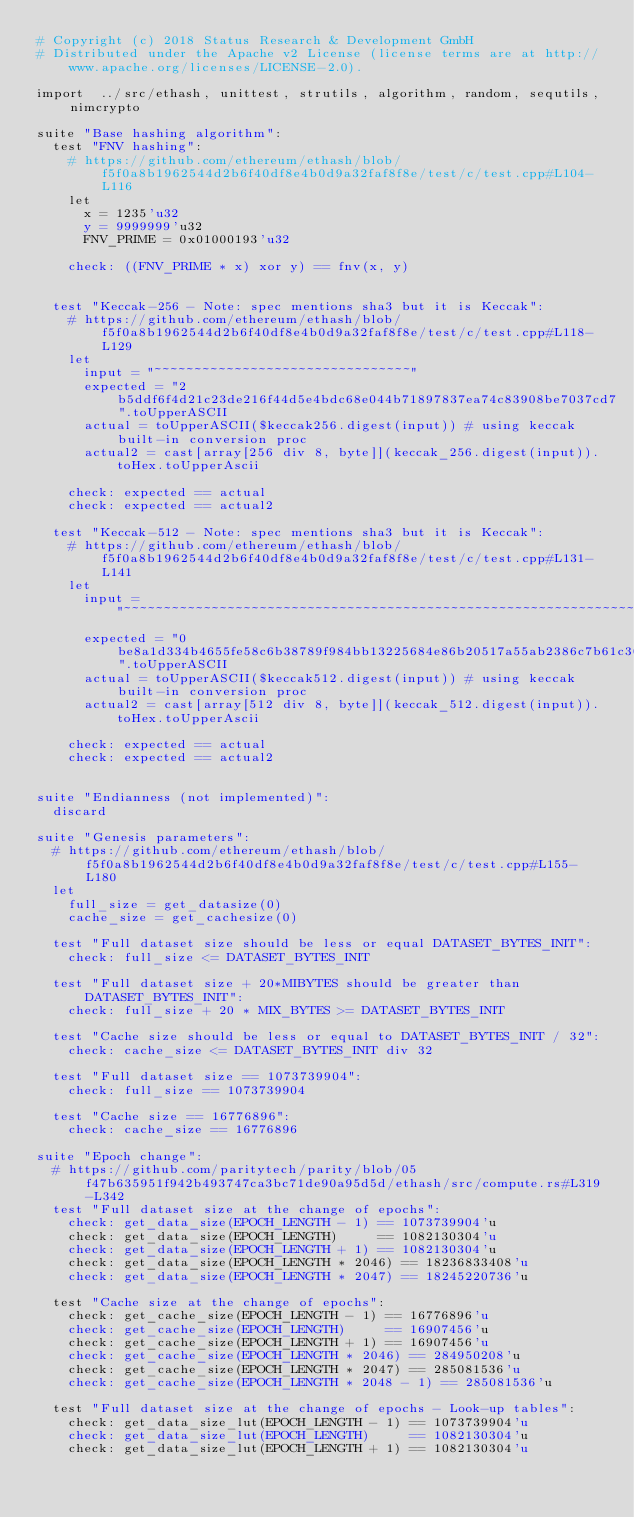<code> <loc_0><loc_0><loc_500><loc_500><_Nim_># Copyright (c) 2018 Status Research & Development GmbH
# Distributed under the Apache v2 License (license terms are at http://www.apache.org/licenses/LICENSE-2.0).

import  ../src/ethash, unittest, strutils, algorithm, random, sequtils, nimcrypto

suite "Base hashing algorithm":
  test "FNV hashing":
    # https://github.com/ethereum/ethash/blob/f5f0a8b1962544d2b6f40df8e4b0d9a32faf8f8e/test/c/test.cpp#L104-L116
    let
      x = 1235'u32
      y = 9999999'u32
      FNV_PRIME = 0x01000193'u32

    check: ((FNV_PRIME * x) xor y) == fnv(x, y)


  test "Keccak-256 - Note: spec mentions sha3 but it is Keccak":
    # https://github.com/ethereum/ethash/blob/f5f0a8b1962544d2b6f40df8e4b0d9a32faf8f8e/test/c/test.cpp#L118-L129
    let
      input = "~~~~~~~~~~~~~~~~~~~~~~~~~~~~~~~~"
      expected = "2b5ddf6f4d21c23de216f44d5e4bdc68e044b71897837ea74c83908be7037cd7".toUpperASCII
      actual = toUpperASCII($keccak256.digest(input)) # using keccak built-in conversion proc
      actual2 = cast[array[256 div 8, byte]](keccak_256.digest(input)).toHex.toUpperAscii

    check: expected == actual
    check: expected == actual2

  test "Keccak-512 - Note: spec mentions sha3 but it is Keccak":
    # https://github.com/ethereum/ethash/blob/f5f0a8b1962544d2b6f40df8e4b0d9a32faf8f8e/test/c/test.cpp#L131-L141
    let
      input = "~~~~~~~~~~~~~~~~~~~~~~~~~~~~~~~~~~~~~~~~~~~~~~~~~~~~~~~~~~~~~~~~"
      expected = "0be8a1d334b4655fe58c6b38789f984bb13225684e86b20517a55ab2386c7b61c306f25e0627c60064cecd6d80cd67a82b3890bd1289b7ceb473aad56a359405".toUpperASCII
      actual = toUpperASCII($keccak512.digest(input)) # using keccak built-in conversion proc
      actual2 = cast[array[512 div 8, byte]](keccak_512.digest(input)).toHex.toUpperAscii

    check: expected == actual
    check: expected == actual2


suite "Endianness (not implemented)":
  discard

suite "Genesis parameters":
  # https://github.com/ethereum/ethash/blob/f5f0a8b1962544d2b6f40df8e4b0d9a32faf8f8e/test/c/test.cpp#L155-L180
  let
    full_size = get_datasize(0)
    cache_size = get_cachesize(0)

  test "Full dataset size should be less or equal DATASET_BYTES_INIT":
    check: full_size <= DATASET_BYTES_INIT

  test "Full dataset size + 20*MIBYTES should be greater than DATASET_BYTES_INIT":
    check: full_size + 20 * MIX_BYTES >= DATASET_BYTES_INIT

  test "Cache size should be less or equal to DATASET_BYTES_INIT / 32":
    check: cache_size <= DATASET_BYTES_INIT div 32

  test "Full dataset size == 1073739904":
    check: full_size == 1073739904

  test "Cache size == 16776896":
    check: cache_size == 16776896

suite "Epoch change":
  # https://github.com/paritytech/parity/blob/05f47b635951f942b493747ca3bc71de90a95d5d/ethash/src/compute.rs#L319-L342
  test "Full dataset size at the change of epochs":
    check: get_data_size(EPOCH_LENGTH - 1) == 1073739904'u
    check: get_data_size(EPOCH_LENGTH)     == 1082130304'u
    check: get_data_size(EPOCH_LENGTH + 1) == 1082130304'u
    check: get_data_size(EPOCH_LENGTH * 2046) == 18236833408'u
    check: get_data_size(EPOCH_LENGTH * 2047) == 18245220736'u

  test "Cache size at the change of epochs":
    check: get_cache_size(EPOCH_LENGTH - 1) == 16776896'u
    check: get_cache_size(EPOCH_LENGTH)     == 16907456'u
    check: get_cache_size(EPOCH_LENGTH + 1) == 16907456'u
    check: get_cache_size(EPOCH_LENGTH * 2046) == 284950208'u
    check: get_cache_size(EPOCH_LENGTH * 2047) == 285081536'u
    check: get_cache_size(EPOCH_LENGTH * 2048 - 1) == 285081536'u

  test "Full dataset size at the change of epochs - Look-up tables":
    check: get_data_size_lut(EPOCH_LENGTH - 1) == 1073739904'u
    check: get_data_size_lut(EPOCH_LENGTH)     == 1082130304'u
    check: get_data_size_lut(EPOCH_LENGTH + 1) == 1082130304'u</code> 